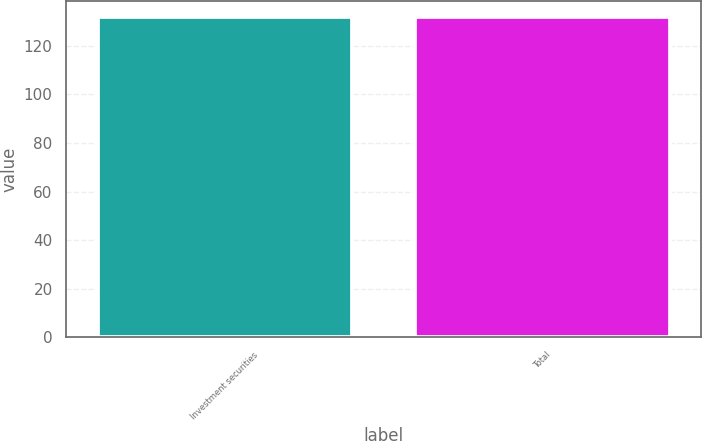Convert chart to OTSL. <chart><loc_0><loc_0><loc_500><loc_500><bar_chart><fcel>Investment securities<fcel>Total<nl><fcel>132<fcel>132.1<nl></chart> 